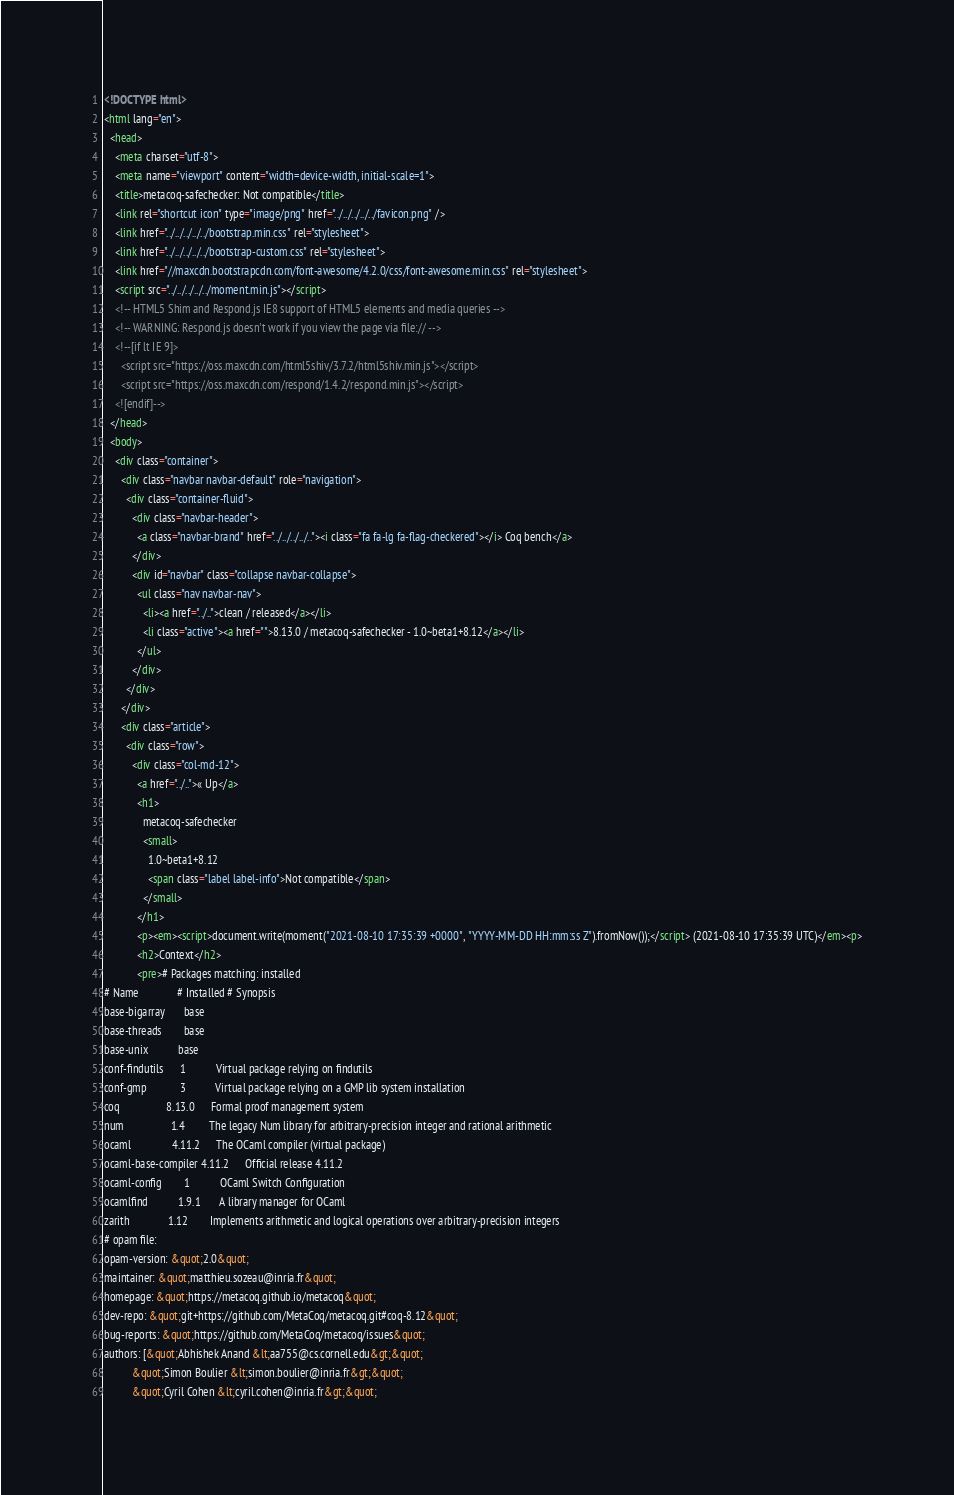Convert code to text. <code><loc_0><loc_0><loc_500><loc_500><_HTML_><!DOCTYPE html>
<html lang="en">
  <head>
    <meta charset="utf-8">
    <meta name="viewport" content="width=device-width, initial-scale=1">
    <title>metacoq-safechecker: Not compatible</title>
    <link rel="shortcut icon" type="image/png" href="../../../../../favicon.png" />
    <link href="../../../../../bootstrap.min.css" rel="stylesheet">
    <link href="../../../../../bootstrap-custom.css" rel="stylesheet">
    <link href="//maxcdn.bootstrapcdn.com/font-awesome/4.2.0/css/font-awesome.min.css" rel="stylesheet">
    <script src="../../../../../moment.min.js"></script>
    <!-- HTML5 Shim and Respond.js IE8 support of HTML5 elements and media queries -->
    <!-- WARNING: Respond.js doesn't work if you view the page via file:// -->
    <!--[if lt IE 9]>
      <script src="https://oss.maxcdn.com/html5shiv/3.7.2/html5shiv.min.js"></script>
      <script src="https://oss.maxcdn.com/respond/1.4.2/respond.min.js"></script>
    <![endif]-->
  </head>
  <body>
    <div class="container">
      <div class="navbar navbar-default" role="navigation">
        <div class="container-fluid">
          <div class="navbar-header">
            <a class="navbar-brand" href="../../../../.."><i class="fa fa-lg fa-flag-checkered"></i> Coq bench</a>
          </div>
          <div id="navbar" class="collapse navbar-collapse">
            <ul class="nav navbar-nav">
              <li><a href="../..">clean / released</a></li>
              <li class="active"><a href="">8.13.0 / metacoq-safechecker - 1.0~beta1+8.12</a></li>
            </ul>
          </div>
        </div>
      </div>
      <div class="article">
        <div class="row">
          <div class="col-md-12">
            <a href="../..">« Up</a>
            <h1>
              metacoq-safechecker
              <small>
                1.0~beta1+8.12
                <span class="label label-info">Not compatible</span>
              </small>
            </h1>
            <p><em><script>document.write(moment("2021-08-10 17:35:39 +0000", "YYYY-MM-DD HH:mm:ss Z").fromNow());</script> (2021-08-10 17:35:39 UTC)</em><p>
            <h2>Context</h2>
            <pre># Packages matching: installed
# Name              # Installed # Synopsis
base-bigarray       base
base-threads        base
base-unix           base
conf-findutils      1           Virtual package relying on findutils
conf-gmp            3           Virtual package relying on a GMP lib system installation
coq                 8.13.0      Formal proof management system
num                 1.4         The legacy Num library for arbitrary-precision integer and rational arithmetic
ocaml               4.11.2      The OCaml compiler (virtual package)
ocaml-base-compiler 4.11.2      Official release 4.11.2
ocaml-config        1           OCaml Switch Configuration
ocamlfind           1.9.1       A library manager for OCaml
zarith              1.12        Implements arithmetic and logical operations over arbitrary-precision integers
# opam file:
opam-version: &quot;2.0&quot;
maintainer: &quot;matthieu.sozeau@inria.fr&quot;
homepage: &quot;https://metacoq.github.io/metacoq&quot;
dev-repo: &quot;git+https://github.com/MetaCoq/metacoq.git#coq-8.12&quot;
bug-reports: &quot;https://github.com/MetaCoq/metacoq/issues&quot;
authors: [&quot;Abhishek Anand &lt;aa755@cs.cornell.edu&gt;&quot;
          &quot;Simon Boulier &lt;simon.boulier@inria.fr&gt;&quot;
          &quot;Cyril Cohen &lt;cyril.cohen@inria.fr&gt;&quot;</code> 